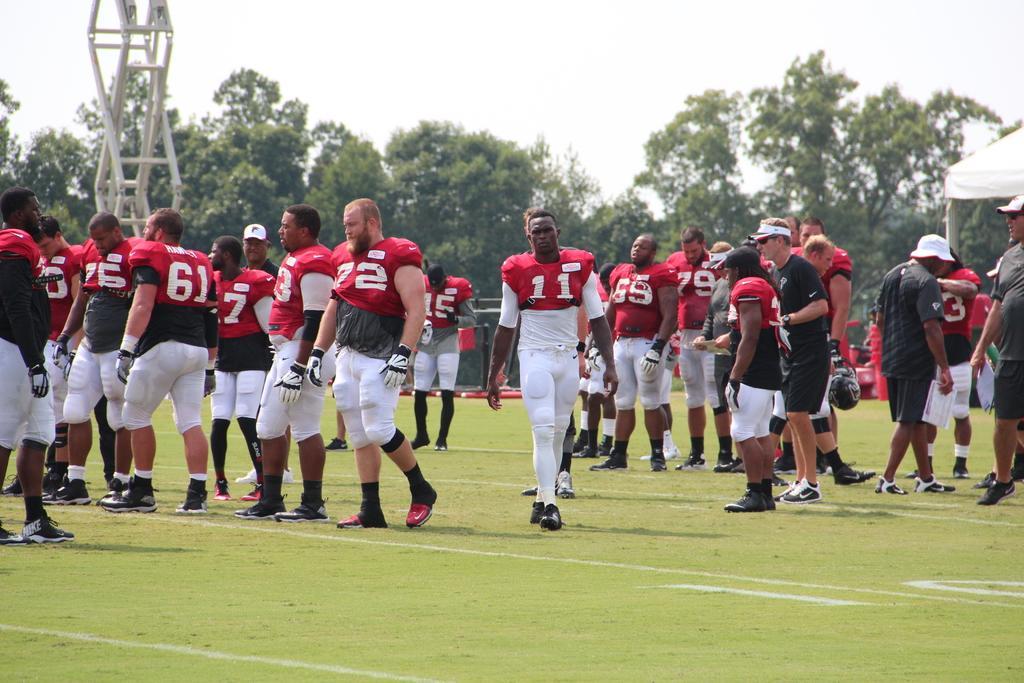Describe this image in one or two sentences. In the center of the image we can see a group of people are standing. And we can see a few people are wearing caps. And we can see a few people are holding some objects. And we can see a few people are in red color t shirt and few are in black t shirt. In the background we can see the sky, clouds, trees, grass, one pole, tent and a few other objects. 